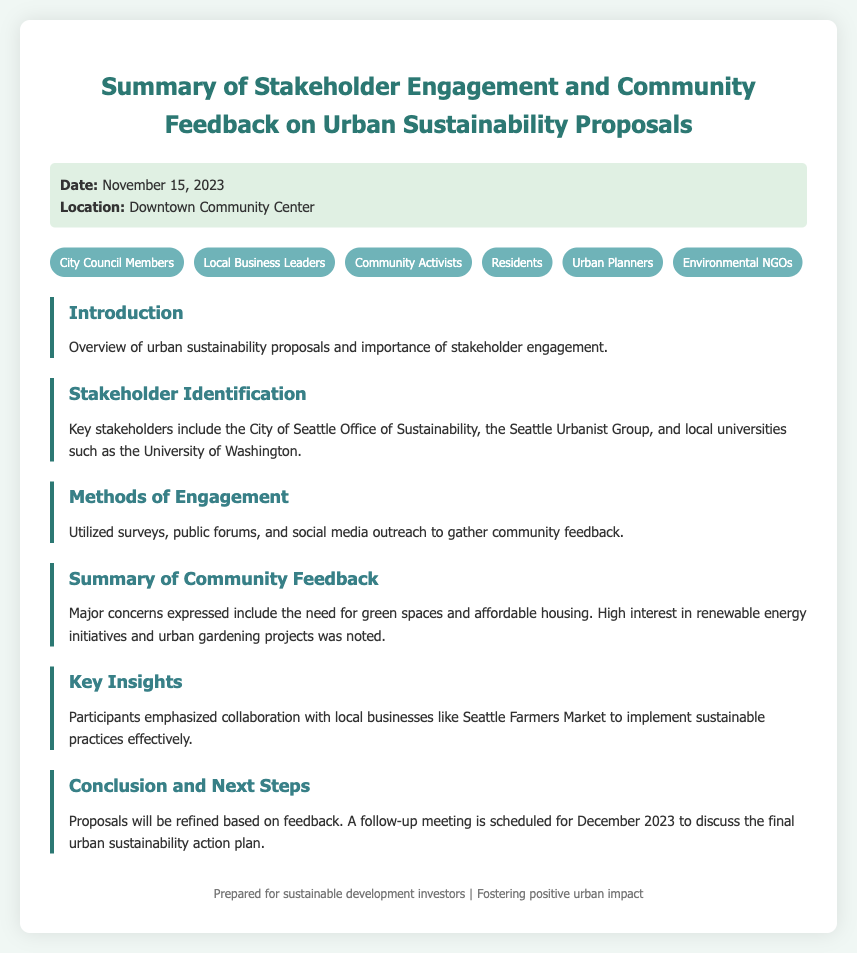What is the date of the meeting? The date of the meeting is listed at the top of the document under meta-info.
Answer: November 15, 2023 Where was the stakeholder engagement held? The location of the engagement is specified in the meta-info section.
Answer: Downtown Community Center Who are the key stakeholders mentioned? The stakeholders are identified in the Stakeholder Identification section of the document.
Answer: City of Seattle Office of Sustainability, Seattle Urbanist Group, local universities What methods were used for community engagement? Engagement methods are outlined in the Methods of Engagement section.
Answer: Surveys, public forums, social media outreach What major concerns were expressed by the community? Major concerns are summarized in the Summary of Community Feedback section.
Answer: Need for green spaces and affordable housing Which local business is mentioned for collaboration? The specific business for collaboration is noted in the Key Insights section.
Answer: Seattle Farmers Market When is the follow-up meeting scheduled? The date for the follow-up meeting is provided in the Conclusion and Next Steps section.
Answer: December 2023 What is a high-interest project noted in the community feedback? High-interest projects are mentioned in the Summary of Community Feedback section.
Answer: Renewable energy initiatives What is the main focus of the proposals discussed? The focus is indicated in the Introduction section of the document.
Answer: Urban sustainability 